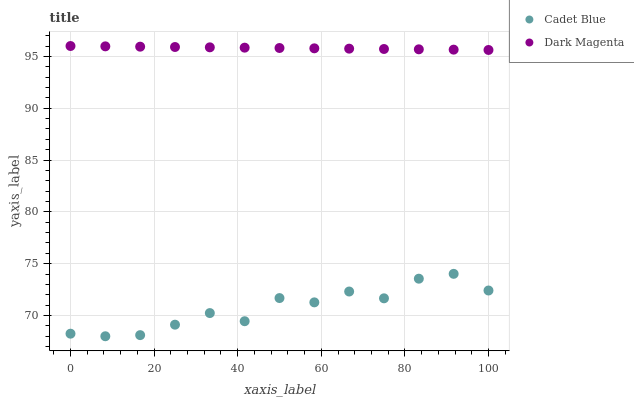Does Cadet Blue have the minimum area under the curve?
Answer yes or no. Yes. Does Dark Magenta have the maximum area under the curve?
Answer yes or no. Yes. Does Dark Magenta have the minimum area under the curve?
Answer yes or no. No. Is Dark Magenta the smoothest?
Answer yes or no. Yes. Is Cadet Blue the roughest?
Answer yes or no. Yes. Is Dark Magenta the roughest?
Answer yes or no. No. Does Cadet Blue have the lowest value?
Answer yes or no. Yes. Does Dark Magenta have the lowest value?
Answer yes or no. No. Does Dark Magenta have the highest value?
Answer yes or no. Yes. Is Cadet Blue less than Dark Magenta?
Answer yes or no. Yes. Is Dark Magenta greater than Cadet Blue?
Answer yes or no. Yes. Does Cadet Blue intersect Dark Magenta?
Answer yes or no. No. 